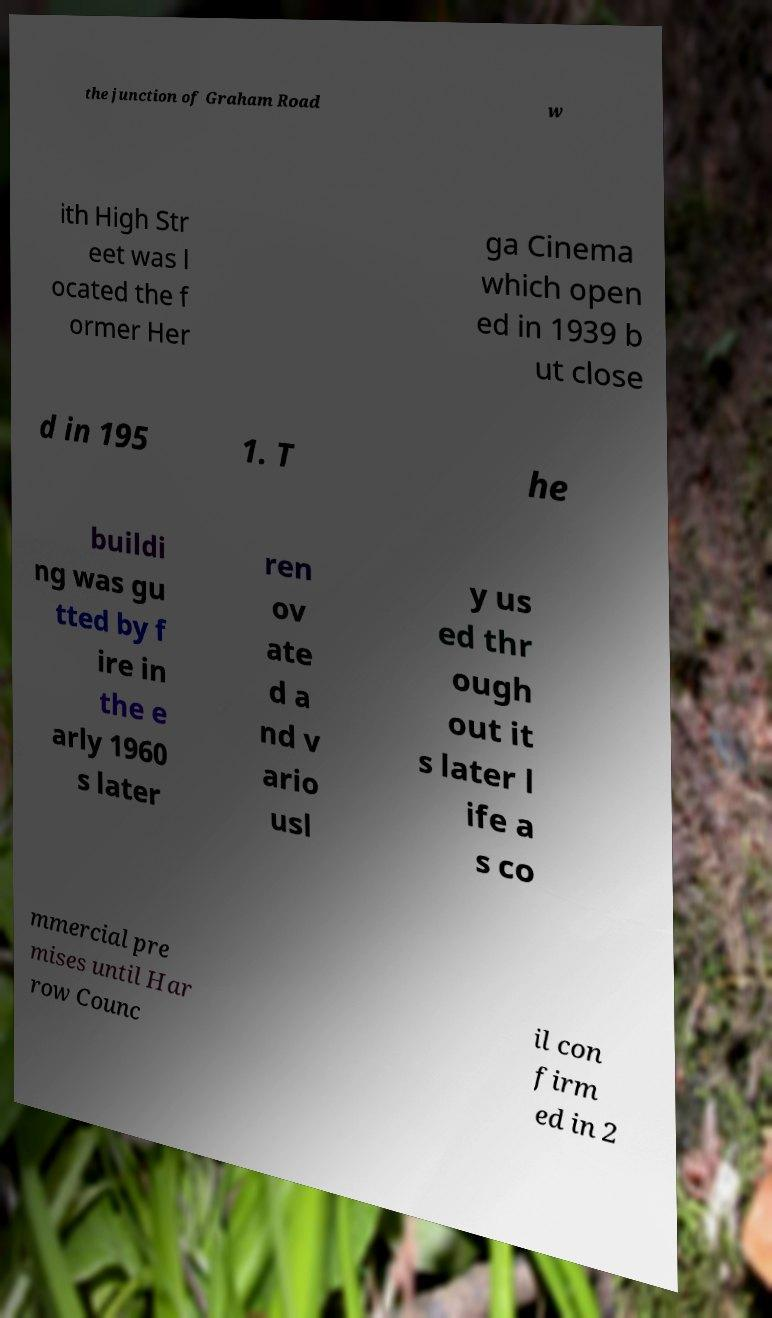Could you assist in decoding the text presented in this image and type it out clearly? the junction of Graham Road w ith High Str eet was l ocated the f ormer Her ga Cinema which open ed in 1939 b ut close d in 195 1. T he buildi ng was gu tted by f ire in the e arly 1960 s later ren ov ate d a nd v ario usl y us ed thr ough out it s later l ife a s co mmercial pre mises until Har row Counc il con firm ed in 2 